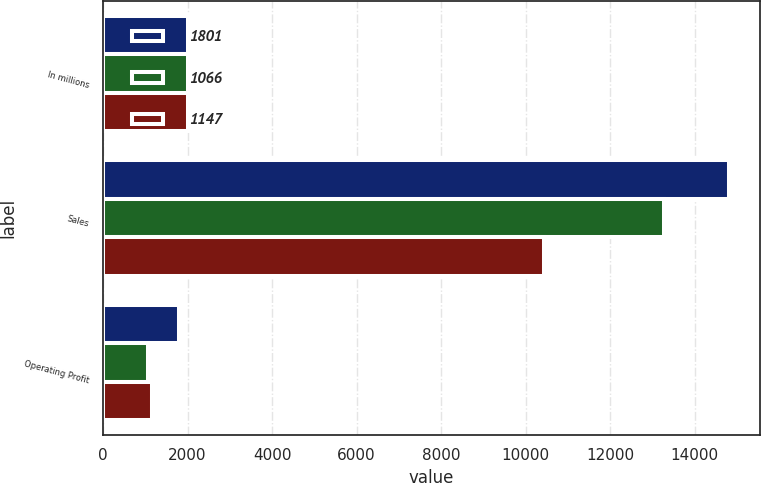Convert chart. <chart><loc_0><loc_0><loc_500><loc_500><stacked_bar_chart><ecel><fcel>In millions<fcel>Sales<fcel>Operating Profit<nl><fcel>1801<fcel>2013<fcel>14810<fcel>1801<nl><fcel>1066<fcel>2012<fcel>13280<fcel>1066<nl><fcel>1147<fcel>2011<fcel>10430<fcel>1147<nl></chart> 